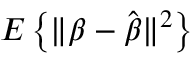Convert formula to latex. <formula><loc_0><loc_0><loc_500><loc_500>E \left \{ \| { \beta } - { \hat { \beta } } \| ^ { 2 } \right \}</formula> 